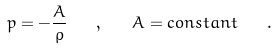Convert formula to latex. <formula><loc_0><loc_0><loc_500><loc_500>p = - \frac { A } { \rho } \quad , \quad A = c o n s t a n t \quad .</formula> 